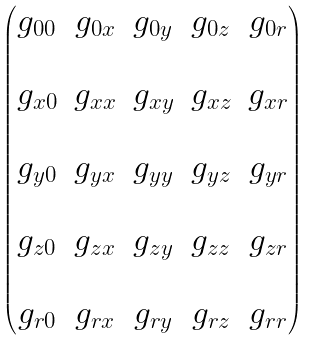Convert formula to latex. <formula><loc_0><loc_0><loc_500><loc_500>\begin{pmatrix} g _ { 0 0 } & g _ { 0 x } & g _ { 0 y } & g _ { 0 z } & g _ { 0 r } \\ & & & & \\ g _ { x 0 } & g _ { x x } & g _ { x y } & g _ { x z } & g _ { x r } \\ & & & & \\ g _ { y 0 } & g _ { y x } & g _ { y y } & g _ { y z } & g _ { y r } \\ & & & & \\ g _ { z 0 } & g _ { z x } & g _ { z y } & g _ { z z } & g _ { z r } \\ & & & & \\ g _ { r 0 } & g _ { r x } & g _ { r y } & g _ { r z } & g _ { r r } \end{pmatrix}</formula> 